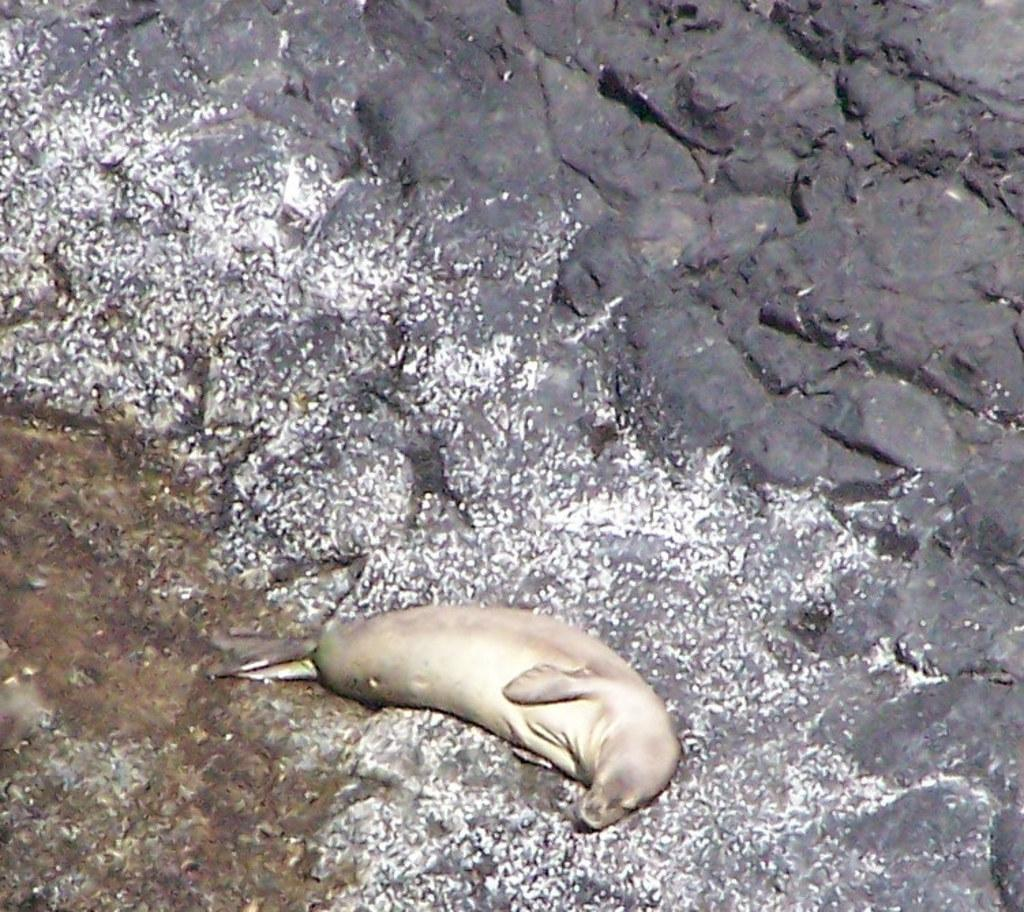What animal can be seen in the image? There is a sea lion in the image. What type of object is on the right side of the image? There is a black rock on the right side of the image. What natural element is visible in the image? Water is visible in the image. Can you describe the possible location of the water? The water might be in the sea. What type of bells can be heard ringing in the image? There are no bells present in the image, so it's not possible to determine what, if any, bells might be heard. 